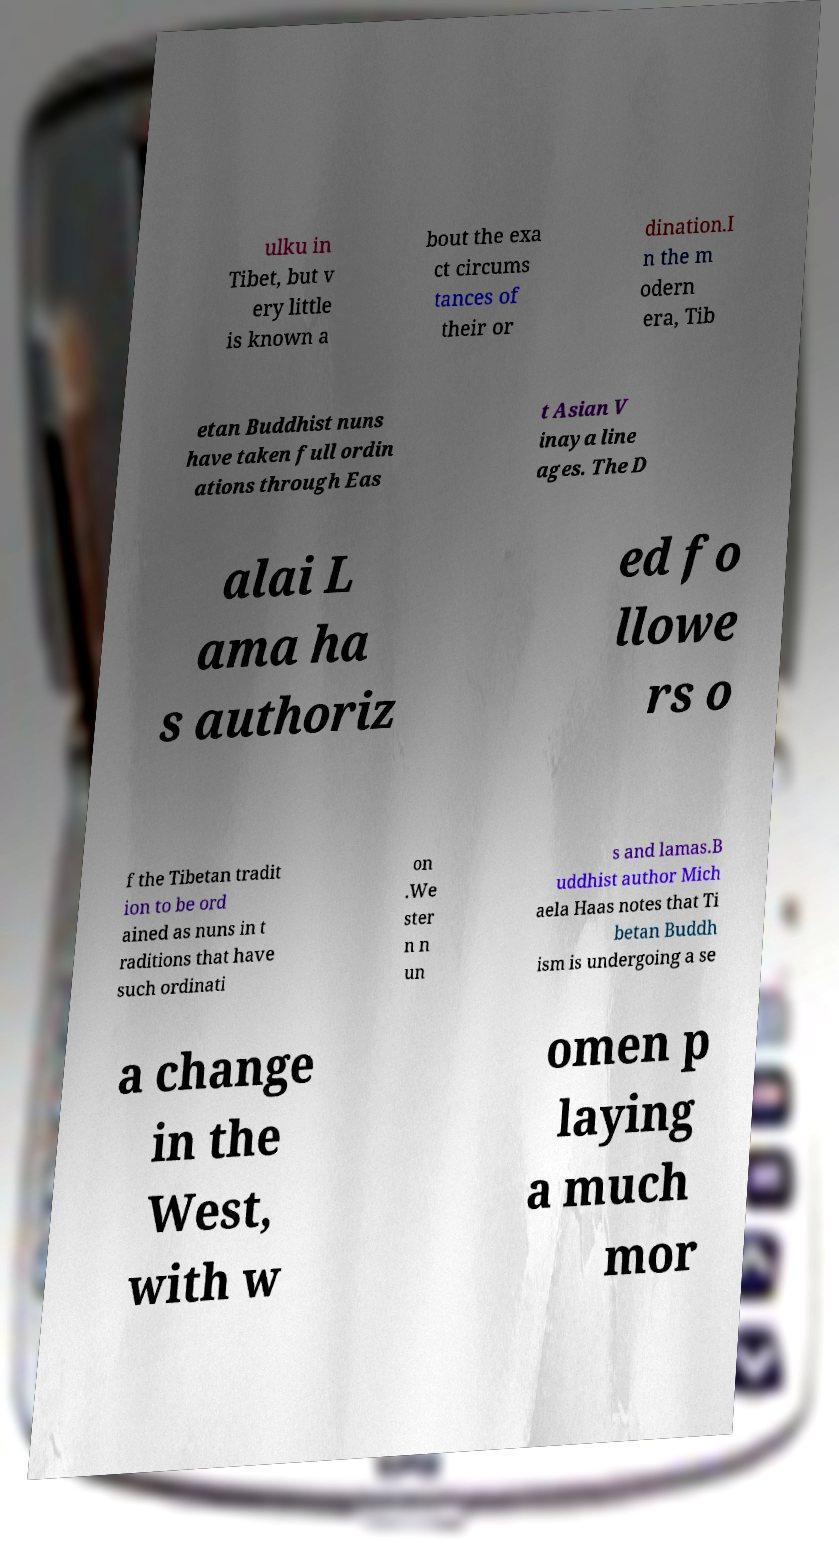Please read and relay the text visible in this image. What does it say? ulku in Tibet, but v ery little is known a bout the exa ct circums tances of their or dination.I n the m odern era, Tib etan Buddhist nuns have taken full ordin ations through Eas t Asian V inaya line ages. The D alai L ama ha s authoriz ed fo llowe rs o f the Tibetan tradit ion to be ord ained as nuns in t raditions that have such ordinati on .We ster n n un s and lamas.B uddhist author Mich aela Haas notes that Ti betan Buddh ism is undergoing a se a change in the West, with w omen p laying a much mor 